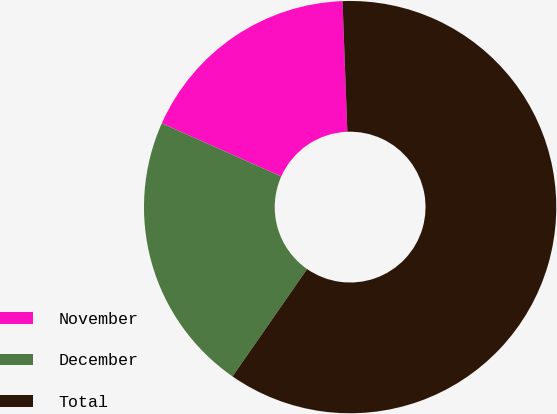<chart> <loc_0><loc_0><loc_500><loc_500><pie_chart><fcel>November<fcel>December<fcel>Total<nl><fcel>17.75%<fcel>22.0%<fcel>60.25%<nl></chart> 